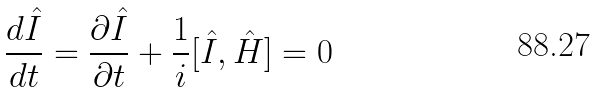<formula> <loc_0><loc_0><loc_500><loc_500>\frac { d \hat { I } } { d t } = \frac { \partial \hat { I } } { \partial t } + \frac { 1 } { i } [ \hat { I } , \hat { H } ] = 0</formula> 